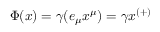Convert formula to latex. <formula><loc_0><loc_0><loc_500><loc_500>\Phi ( x ) = \gamma ( e _ { \mu } x ^ { \mu } ) = \gamma x ^ { ( + ) }</formula> 